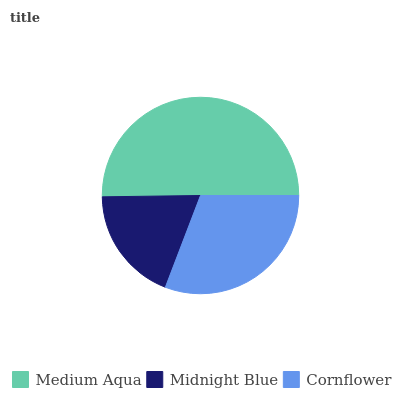Is Midnight Blue the minimum?
Answer yes or no. Yes. Is Medium Aqua the maximum?
Answer yes or no. Yes. Is Cornflower the minimum?
Answer yes or no. No. Is Cornflower the maximum?
Answer yes or no. No. Is Cornflower greater than Midnight Blue?
Answer yes or no. Yes. Is Midnight Blue less than Cornflower?
Answer yes or no. Yes. Is Midnight Blue greater than Cornflower?
Answer yes or no. No. Is Cornflower less than Midnight Blue?
Answer yes or no. No. Is Cornflower the high median?
Answer yes or no. Yes. Is Cornflower the low median?
Answer yes or no. Yes. Is Medium Aqua the high median?
Answer yes or no. No. Is Midnight Blue the low median?
Answer yes or no. No. 